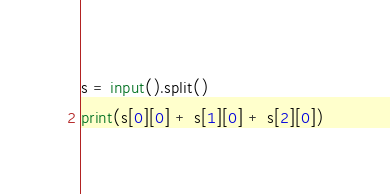<code> <loc_0><loc_0><loc_500><loc_500><_Python_>s = input().split()
print(s[0][0] + s[1][0] + s[2][0])</code> 